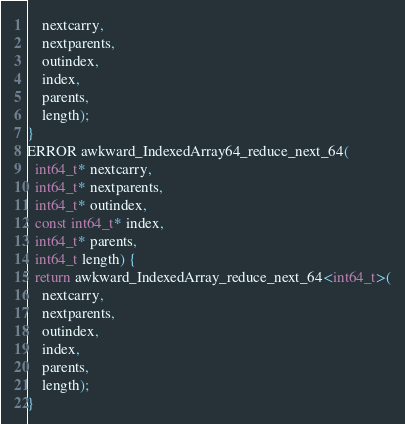<code> <loc_0><loc_0><loc_500><loc_500><_C++_>    nextcarry,
    nextparents,
    outindex,
    index,
    parents,
    length);
}
ERROR awkward_IndexedArray64_reduce_next_64(
  int64_t* nextcarry,
  int64_t* nextparents,
  int64_t* outindex,
  const int64_t* index,
  int64_t* parents,
  int64_t length) {
  return awkward_IndexedArray_reduce_next_64<int64_t>(
    nextcarry,
    nextparents,
    outindex,
    index,
    parents,
    length);
}
</code> 